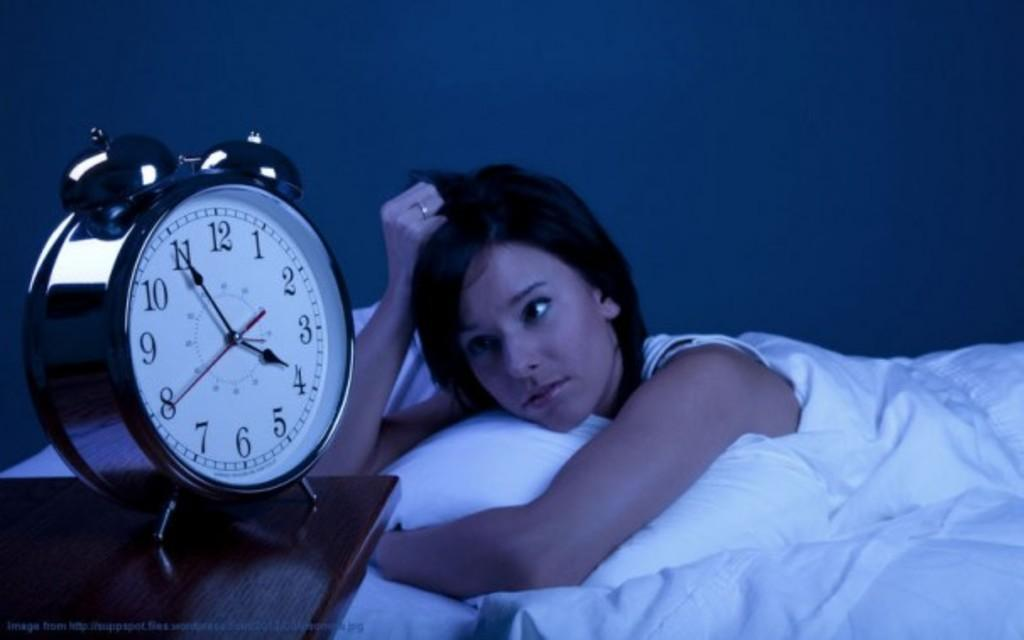<image>
Relay a brief, clear account of the picture shown. A woman in bed watches as the clock turns 4. 